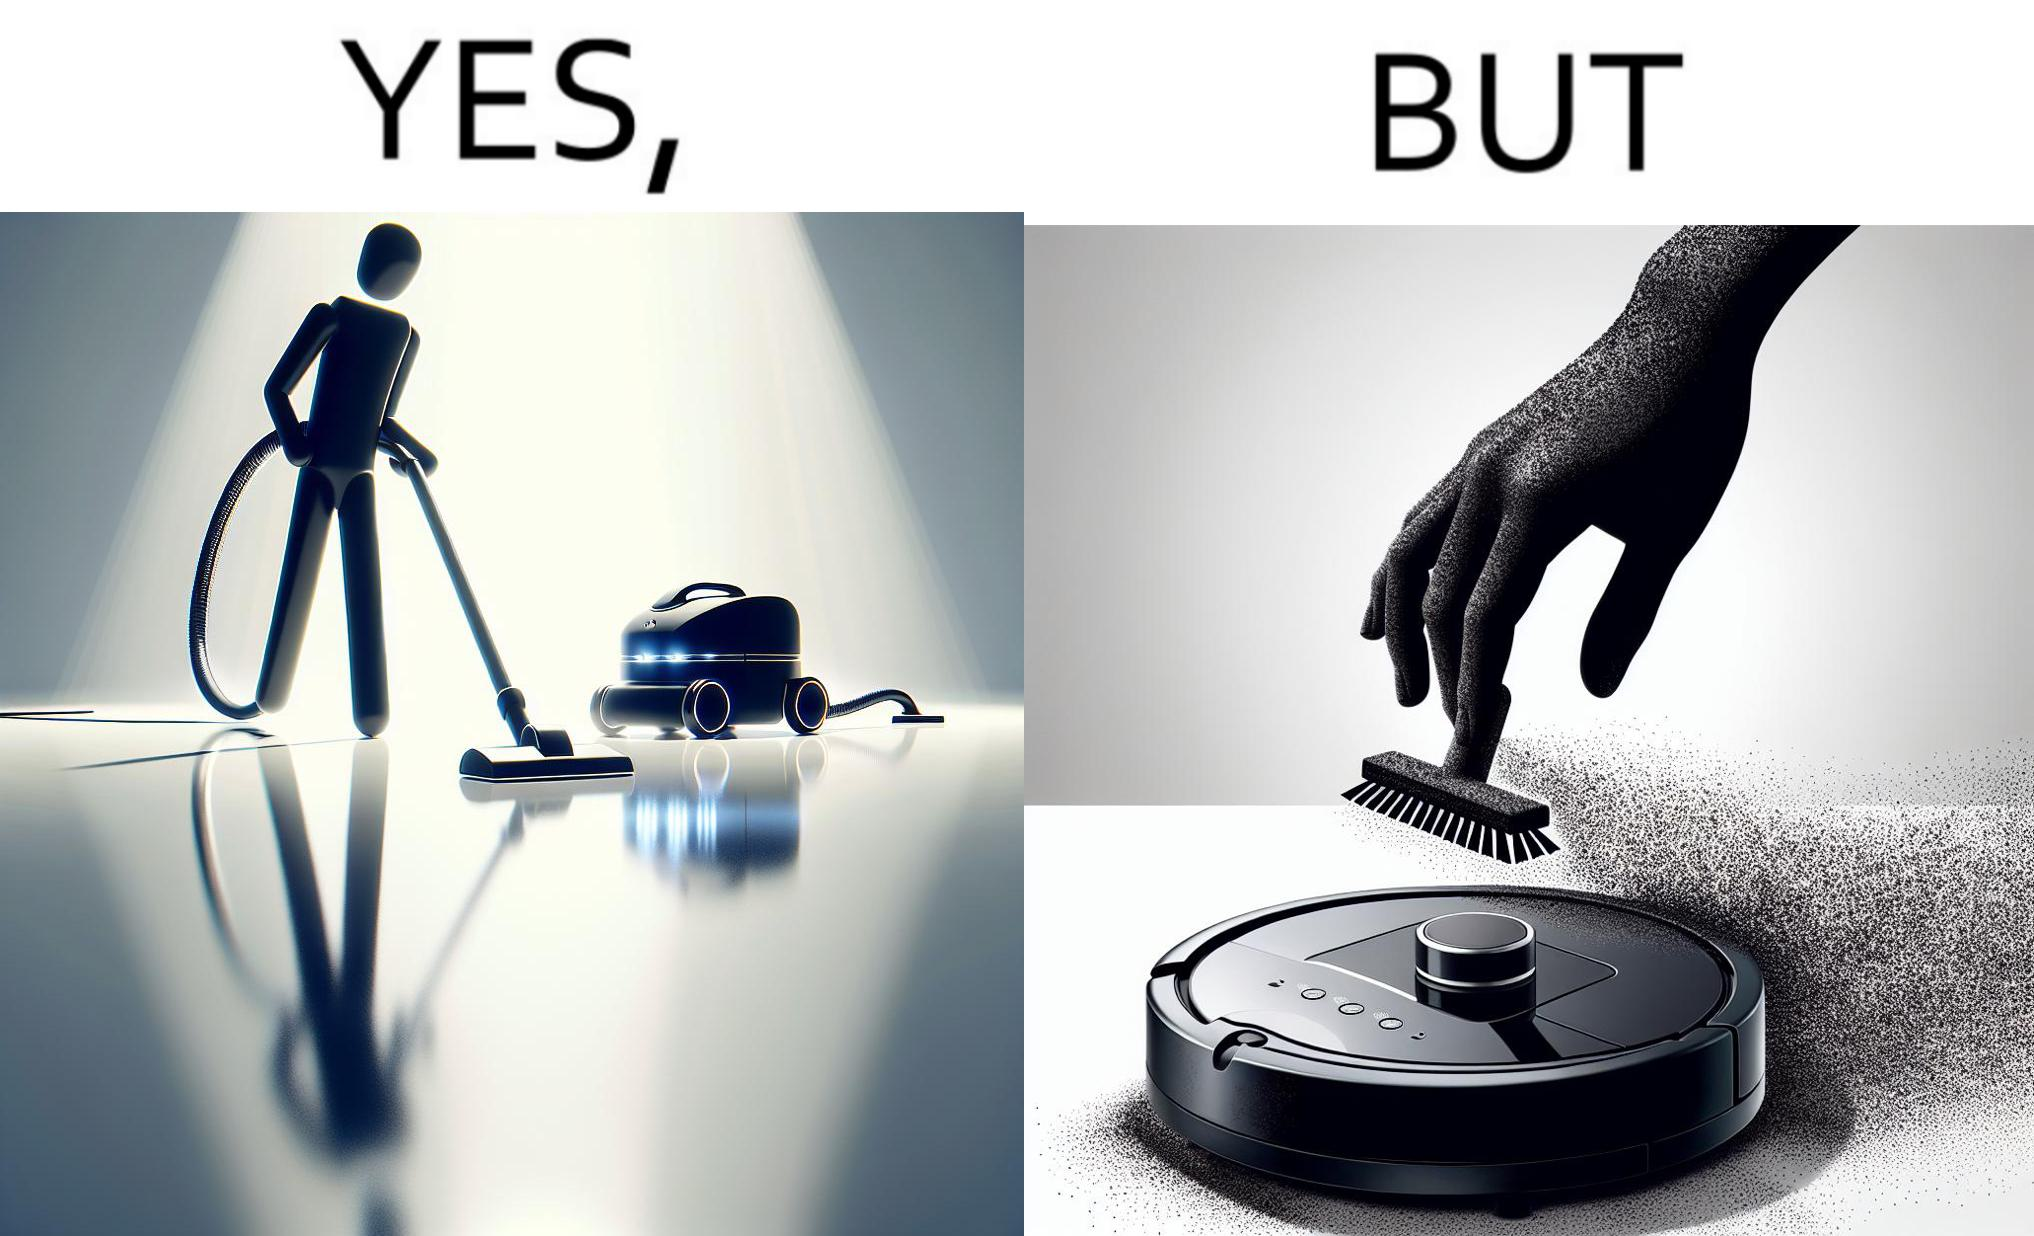Provide a description of this image. This is funny, because the machine while doing its job cleans everything but ends up being dirty itself. 